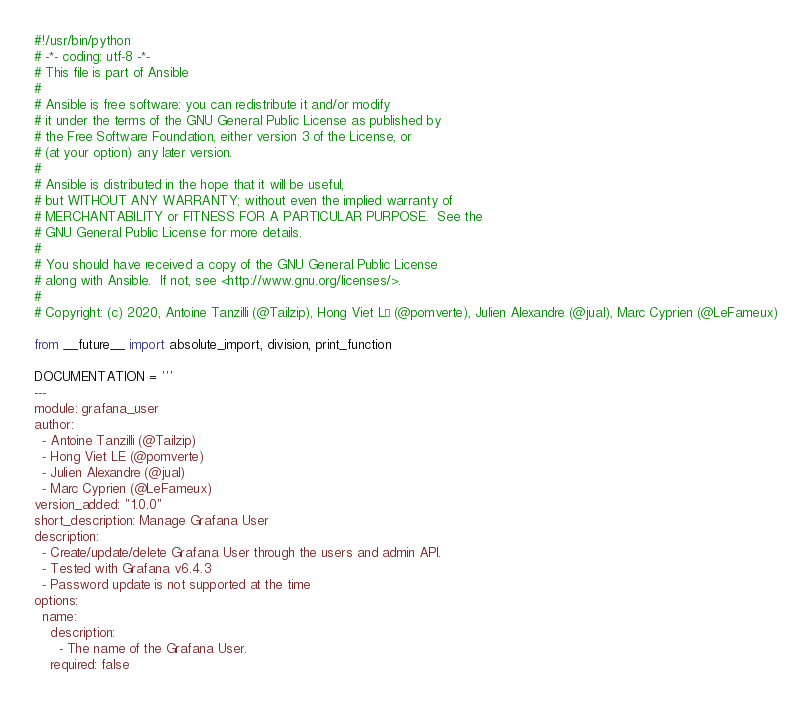Convert code to text. <code><loc_0><loc_0><loc_500><loc_500><_Python_>#!/usr/bin/python
# -*- coding: utf-8 -*-
# This file is part of Ansible
#
# Ansible is free software: you can redistribute it and/or modify
# it under the terms of the GNU General Public License as published by
# the Free Software Foundation, either version 3 of the License, or
# (at your option) any later version.
#
# Ansible is distributed in the hope that it will be useful,
# but WITHOUT ANY WARRANTY; without even the implied warranty of
# MERCHANTABILITY or FITNESS FOR A PARTICULAR PURPOSE.  See the
# GNU General Public License for more details.
#
# You should have received a copy of the GNU General Public License
# along with Ansible.  If not, see <http://www.gnu.org/licenses/>.
#
# Copyright: (c) 2020, Antoine Tanzilli (@Tailzip), Hong Viet Lê (@pomverte), Julien Alexandre (@jual), Marc Cyprien (@LeFameux)

from __future__ import absolute_import, division, print_function

DOCUMENTATION = '''
---
module: grafana_user
author:
  - Antoine Tanzilli (@Tailzip)
  - Hong Viet LE (@pomverte)
  - Julien Alexandre (@jual)
  - Marc Cyprien (@LeFameux)
version_added: "1.0.0"
short_description: Manage Grafana User
description:
  - Create/update/delete Grafana User through the users and admin API.
  - Tested with Grafana v6.4.3
  - Password update is not supported at the time
options:
  name:
    description:
      - The name of the Grafana User.
    required: false</code> 